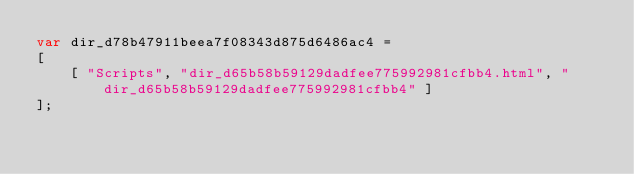<code> <loc_0><loc_0><loc_500><loc_500><_JavaScript_>var dir_d78b47911beea7f08343d875d6486ac4 =
[
    [ "Scripts", "dir_d65b58b59129dadfee775992981cfbb4.html", "dir_d65b58b59129dadfee775992981cfbb4" ]
];</code> 